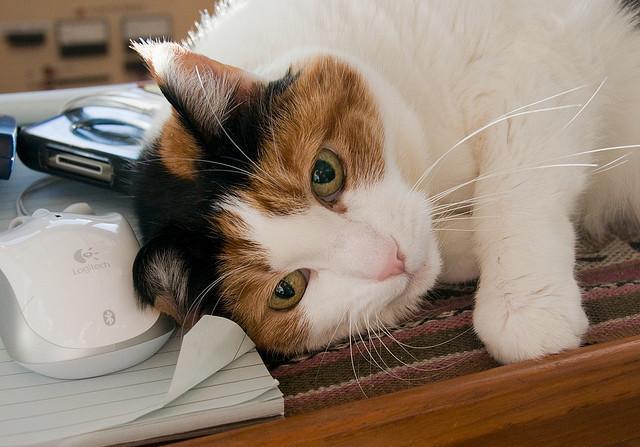How many books are there?
Give a very brief answer. 1. 